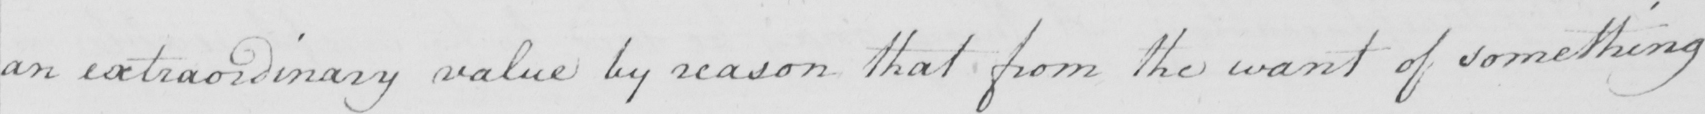Please transcribe the handwritten text in this image. an extraordinary value by reason that from the want of something 